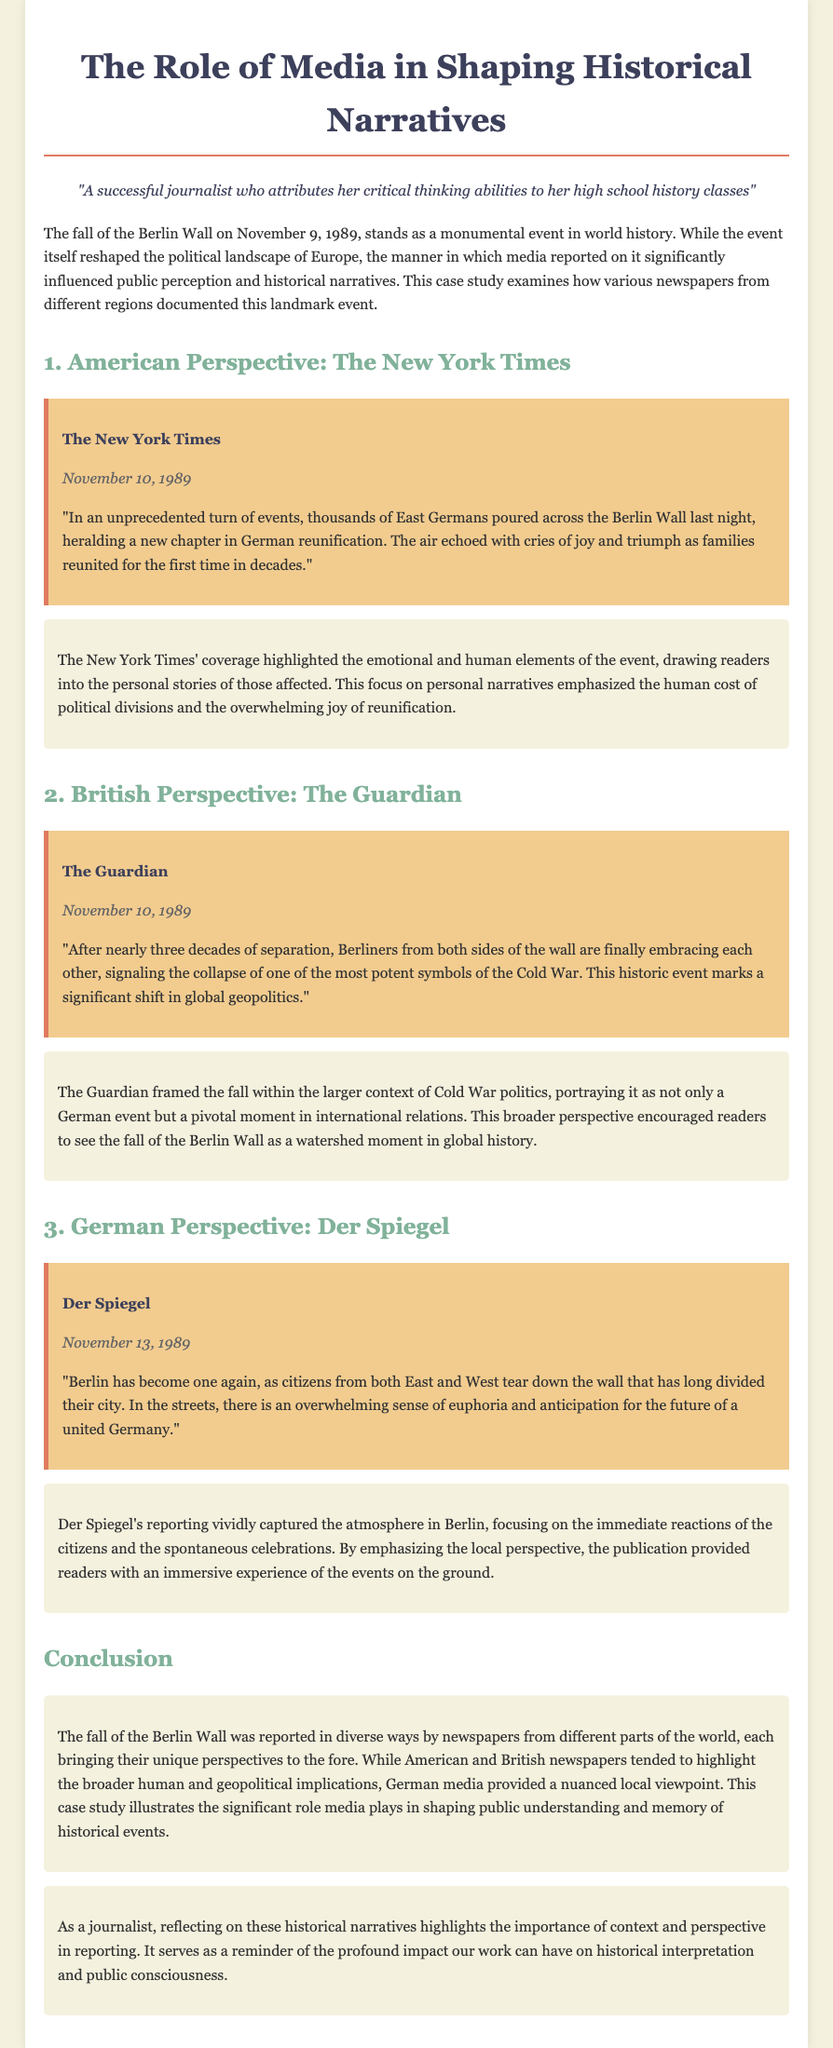what date did the Berlin Wall fall? The document states that the Berlin Wall fell on November 9, 1989.
Answer: November 9, 1989 which newspaper reported on the fall of the Berlin Wall on November 10, 1989? The New York Times and The Guardian both reported on November 10, 1989.
Answer: The New York Times what significant symbol does The Guardian mention in its report? The Guardian mentions the Berlin Wall as a potent symbol of the Cold War.
Answer: Berlin Wall how does Der Spiegel describe the reactions in Berlin after the wall fell? Der Spiegel captures the overwhelming sense of euphoria and anticipation for the future among citizens.
Answer: euphoria and anticipation which newspaper emphasized the human cost of political divisions? The New York Times emphasized the human cost of political divisions through personal narratives.
Answer: The New York Times what broader context does The Guardian provide for the fall of the Berlin Wall? The Guardian frames the fall within the context of global geopolitics and Cold War politics.
Answer: Cold War politics how does the case study conclude regarding the role of media? The conclusion discusses the significant role media plays in shaping public understanding and memory of historical events.
Answer: shaping public understanding what type of perspective does German media provide in this case study? German media, specifically Der Spiegel, provides a nuanced local viewpoint of the events.
Answer: nuanced local viewpoint 